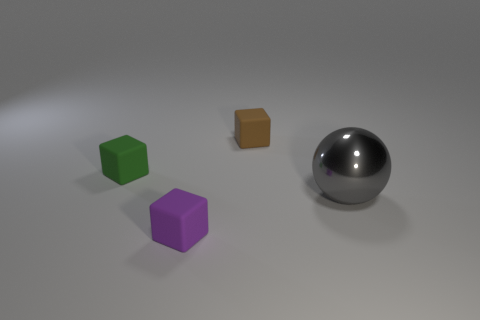Are there any other things that are made of the same material as the large gray ball?
Your answer should be very brief. No. There is a matte block on the left side of the tiny object that is in front of the gray metallic object; is there a tiny matte object behind it?
Your answer should be compact. Yes. There is a large thing; are there any green matte objects on the left side of it?
Provide a short and direct response. Yes. What number of other things are the same shape as the big thing?
Provide a succinct answer. 0. Is the number of small rubber blocks that are behind the brown object less than the number of small objects behind the tiny purple rubber cube?
Provide a short and direct response. Yes. There is a small block that is on the right side of the thing that is in front of the metal object; what number of rubber blocks are left of it?
Offer a very short reply. 2. The green matte thing that is the same shape as the tiny brown rubber thing is what size?
Give a very brief answer. Small. Are there any other things that have the same size as the sphere?
Offer a terse response. No. Is the number of small blocks to the left of the small green matte thing less than the number of large gray balls?
Give a very brief answer. Yes. Is the purple rubber thing the same shape as the green object?
Ensure brevity in your answer.  Yes. 